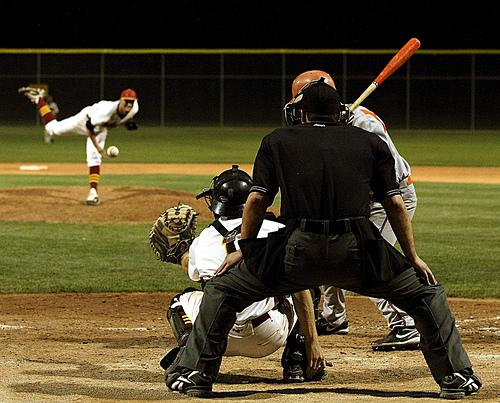Select the dominant color elements from the following: glove, helmet, shoe, socks, and baseball cap. Baseball cap: red baseball cap worn by the pitcher. Point out the various baseball equipment present in the image. Glove, helmet, shoe, bat, ball, catcher's mitt, umpire's outfit, baseball cap, second base, and home plate are present in the image. Describe the appearance and position of the baseball batter. The baseball batter is about to swing at a pitch, wearing a red helmet, holding a red and brown bat, and has the number on his back. Identify the target and current location of the thrown baseball. The baseball is in midair, flying through the air towards home plate, heading to the batter who is about to swing at the pitch. Describe the scene taking place on a baseball field in this image. The scene includes a pitcher throwing a baseball, a catcher crouching down to receive the pitch, a batter anticipating the ball, an umpire observing the play, and several elements of the baseball field such as grass, dirt, and bases. What is the color and texture of the baseball field? The baseball field has green grass and brown dirt, which is seen on the pitchers mound and around the second base. What is the baseball pitcher doing in this image? The pitcher is raising his leg and bent forward on the mound, completing his windup and throwing the baseball in motion. Describe the catcher's position and attire. The baseball catcher is crouching down, wearing a helmet, a catchers mitt, a strap of chest plate, and has straps on his back. Identify the elements of the image related to protective gear. Helmet, catchers mitt, chest plate, baseball cap, and the umpire's outfit are representative of protective gear in the image. What is the umpire wearing in this image? The umpire is wearing a black shirt, white and black shoes, a brown belt, and has his legs spread wide for stability. Does the baseball player have a blue and green bat? The bat in the image is described as red and brown, so asking about a blue and green bat is misleading. Can you see a large yellow umbrella present in the image? No, it's not mentioned in the image. Is the glove on the baseball player purple and white? The glove in the image is not described with any colors, so it's misleading to ask specifically about purple and white. Is the umpire wearing a pink shirt? The umpire's shirt in the image is described as black, so asking about a pink shirt is misleading. Is the baseball in the air surrounded by blue sparkles? The baseball in the image is described as flying in the air or in motion, but there's no mention of any sparkles, especially not blue ones. 